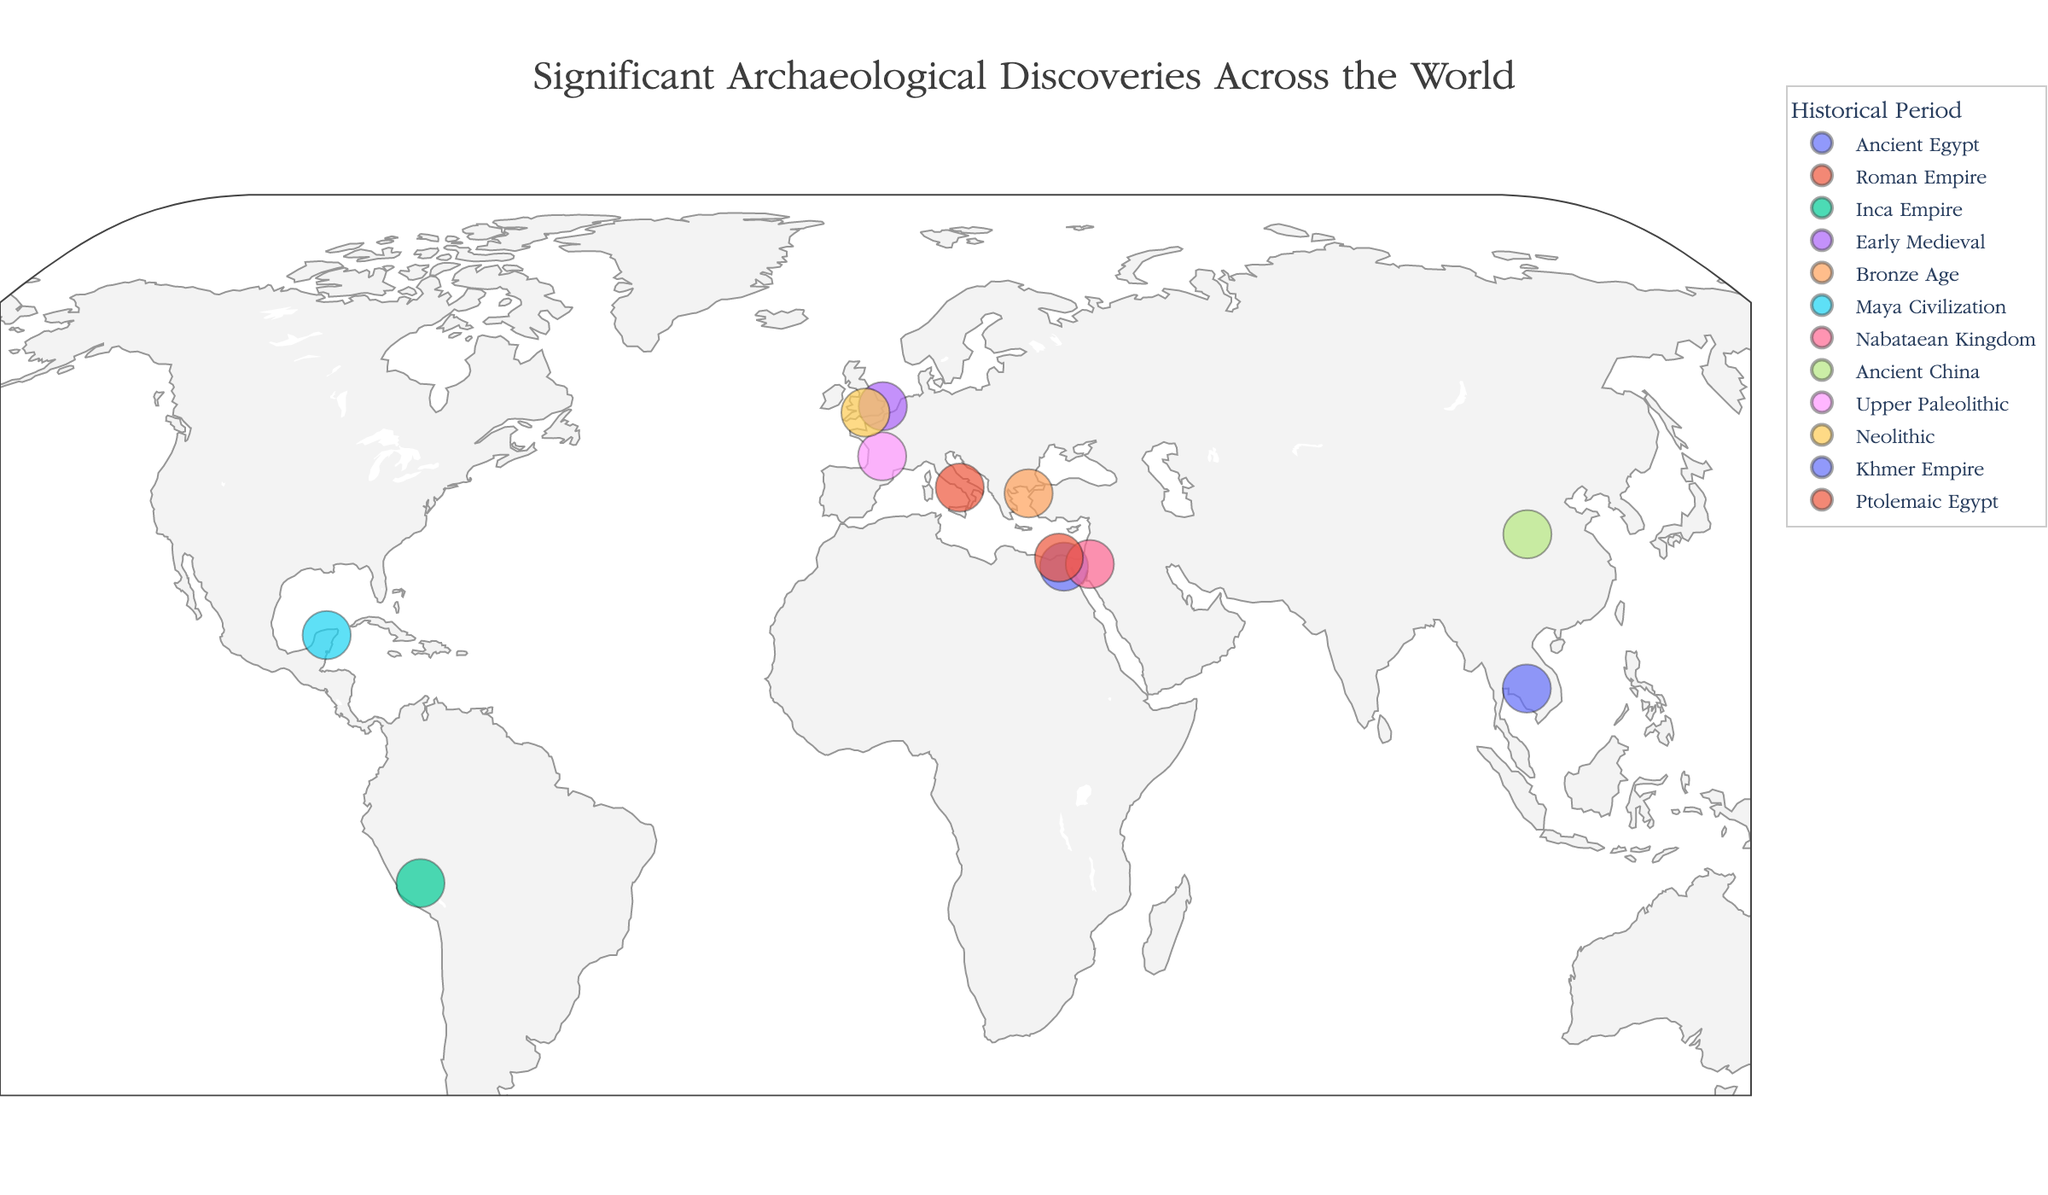What is the title of the plot? The title is displayed prominently at the top center of the figure. By reading this text, you can confirm the title.
Answer: Significant Archaeological Discoveries Across the World How many discoveries from the Roman Empire are shown on the map? Look at the colors representing different periods in the legend. Identify the color for the Roman Empire and count the corresponding data points.
Answer: 1 What period has the most archaeological discoveries on the map? Refer to the color legend to identify different periods. Count the number of data points for each period and compare the counts to determine which period has the most discoveries.
Answer: Ancient Egypt Which two discoveries are the closest together on the map? Examine the geographic positions of the data points by their latitude and longitude. Estimate the distance between them to find the pair that is geographically closest.
Answer: Great Pyramid of Giza and Rosetta Stone Which site is located furthest south? Review the latitudes of all the data points on the map. The point with the smallest (most negative) latitude value is the furthest south.
Answer: Machu Picchu How many discoveries are located in Africa? Identify the region of Africa on the map. Count the data points located within the continent's boundaries.
Answer: 3 Which discovery is located at the easternmost longitude? Examine the longitudes of all data points on the map. The point with the highest longitude value will be the easternmost.
Answer: Terracotta Army Which discovery is positioned at 40.7462 degrees latitude? Look for the data point at 40.7462 latitude on the map. Cross-reference the latitude with the corresponding discovery point.
Answer: Preserved Roman City, Pompeii Compare: Are there more discoveries located in Europe or Asia? Count the number of data points within the geographic boundaries of Europe and Asia separately. Compare these two counts to determine which continent has more discoveries.
Answer: Europe Which historical period has the highest density of discoveries in a single continent? Identify the periods and their respective data points from the legend. Determine which period has the most data points clustered within a single continent.
Answer: Neolithic (Europe) 